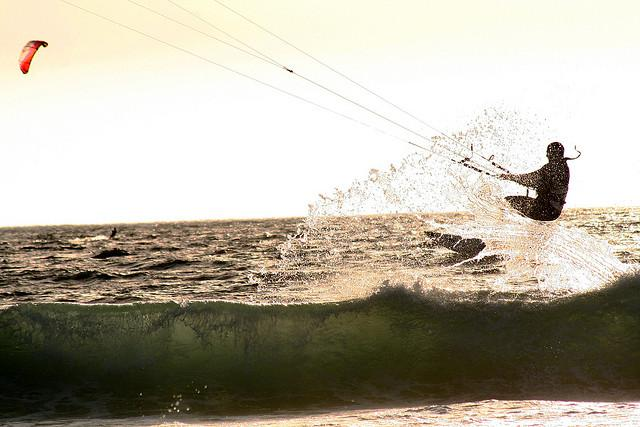The canopy wing is used for? Please explain your reasoning. parasailing. This is used for parasailing. 